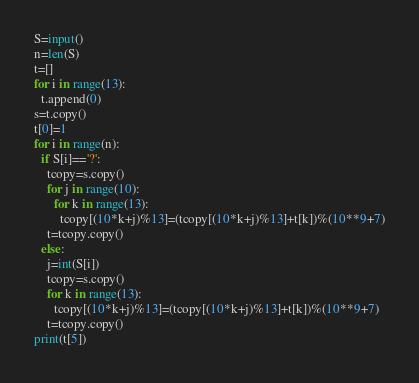<code> <loc_0><loc_0><loc_500><loc_500><_Python_>S=input()
n=len(S)
t=[]
for i in range(13):
  t.append(0)
s=t.copy()
t[0]=1
for i in range(n):
  if S[i]=='?':
    tcopy=s.copy()
    for j in range(10):
      for k in range(13):
        tcopy[(10*k+j)%13]=(tcopy[(10*k+j)%13]+t[k])%(10**9+7)
    t=tcopy.copy()
  else:
    j=int(S[i])
    tcopy=s.copy()
    for k in range(13):
      tcopy[(10*k+j)%13]=(tcopy[(10*k+j)%13]+t[k])%(10**9+7)
    t=tcopy.copy()
print(t[5])</code> 